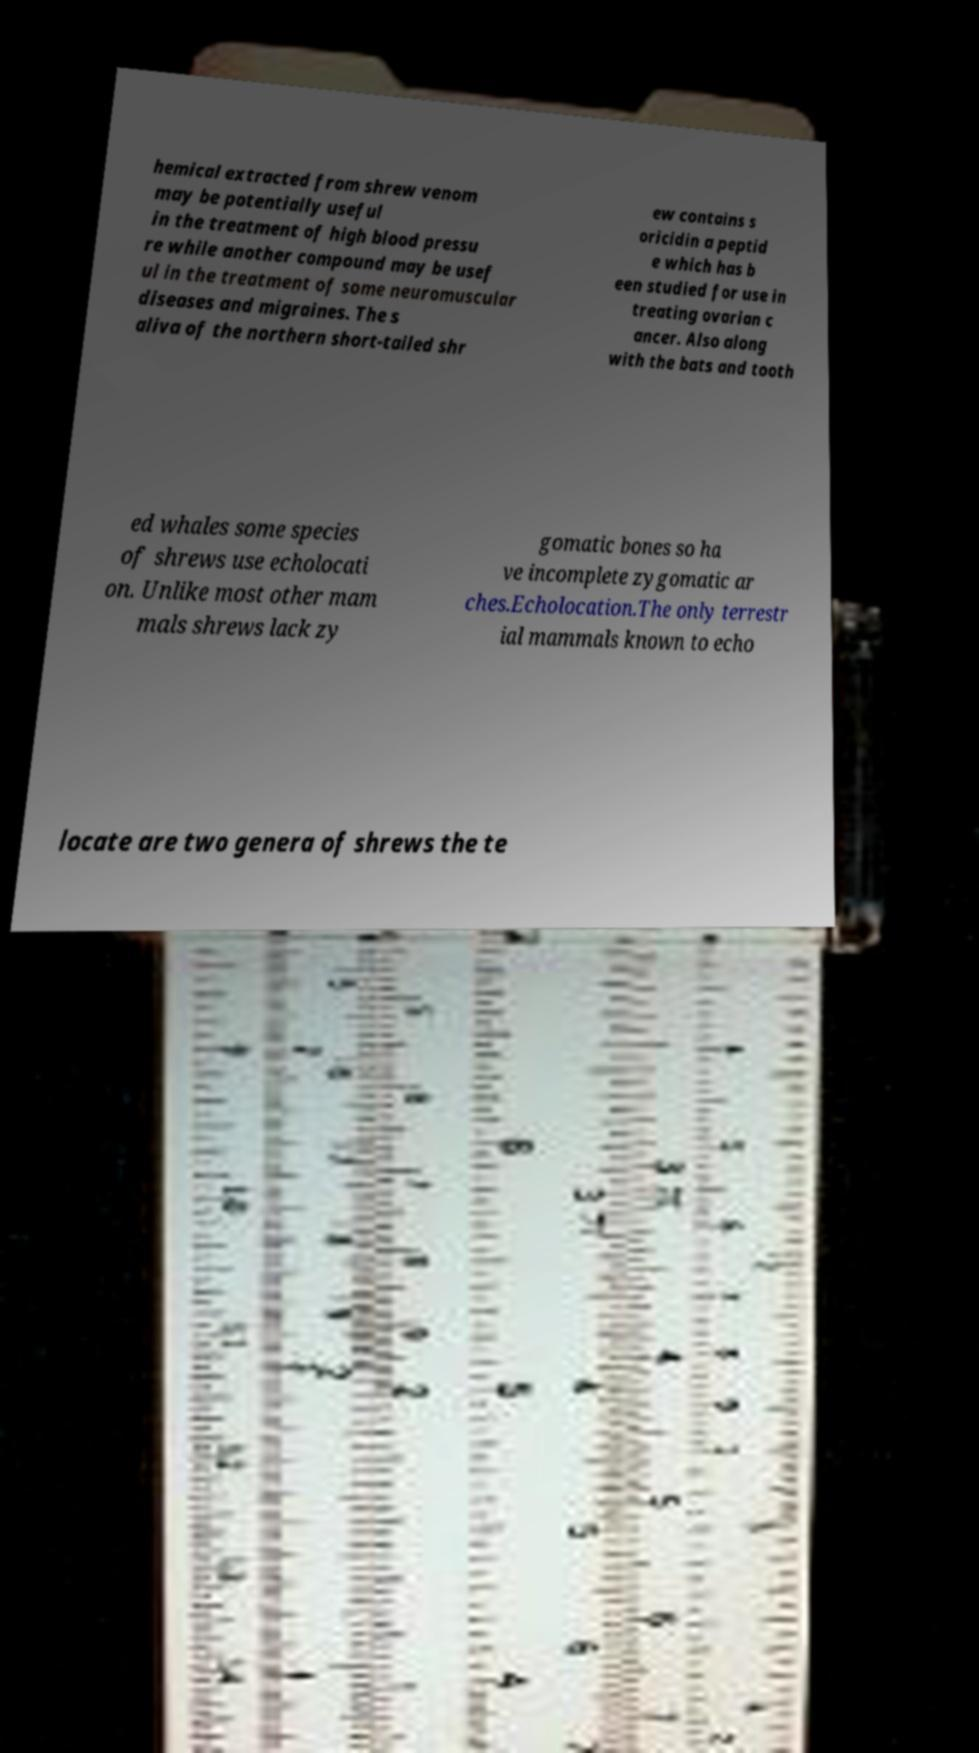Could you extract and type out the text from this image? hemical extracted from shrew venom may be potentially useful in the treatment of high blood pressu re while another compound may be usef ul in the treatment of some neuromuscular diseases and migraines. The s aliva of the northern short-tailed shr ew contains s oricidin a peptid e which has b een studied for use in treating ovarian c ancer. Also along with the bats and tooth ed whales some species of shrews use echolocati on. Unlike most other mam mals shrews lack zy gomatic bones so ha ve incomplete zygomatic ar ches.Echolocation.The only terrestr ial mammals known to echo locate are two genera of shrews the te 